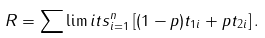<formula> <loc_0><loc_0><loc_500><loc_500>R = \sum \lim i t s _ { i = 1 } ^ { n } \left [ ( 1 - p ) t _ { 1 i } + p t _ { 2 i } \right ] .</formula> 